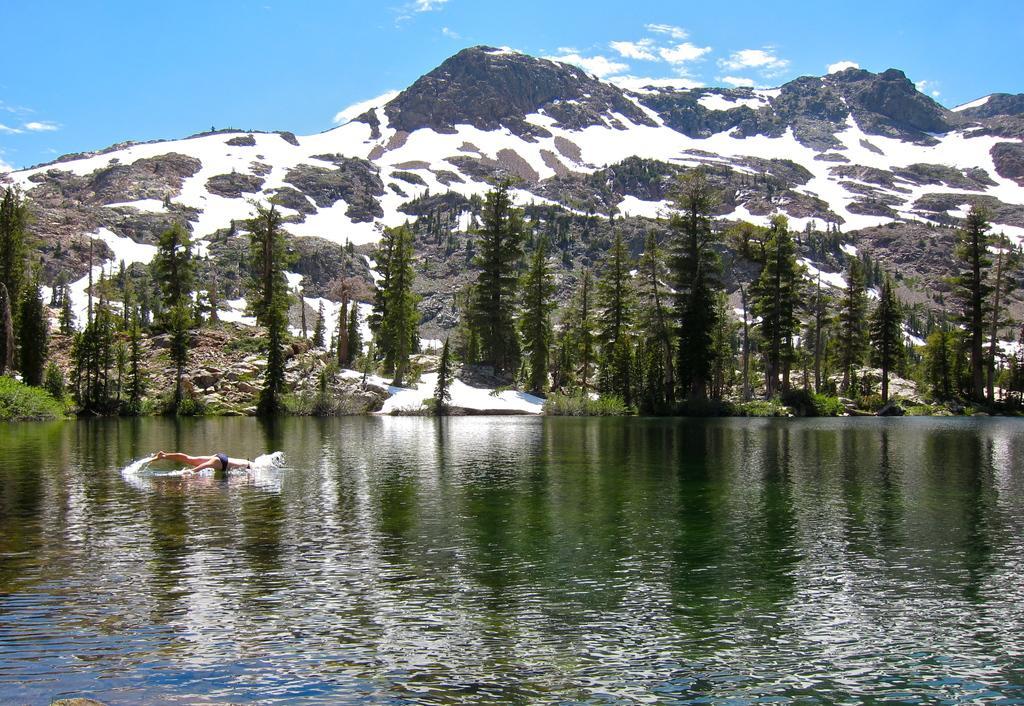Could you give a brief overview of what you see in this image? In this image I can see on the left side a person is jumping into this matter, in the middle there are trees. At the background there are hills with the snow, at the top it is the cloudy sky. 